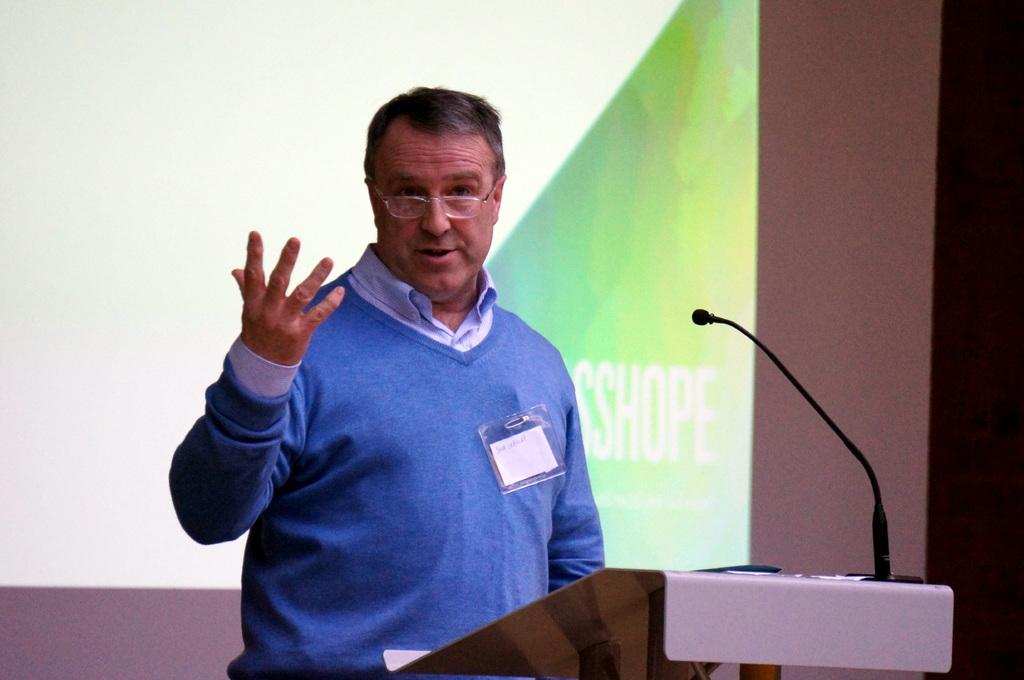What is the man doing at the podium in the image? The man is standing at the podium in the image. What is on the podium with the man? There is a microphone and papers on the podium. What can be seen in the background of the image? There is a screen in the background. What holiday is being celebrated in the image? There is no indication of a holiday being celebrated in the image. What is the level of excitement among the audience in the image? The image does not show an audience, so it is impossible to determine their level of excitement. 